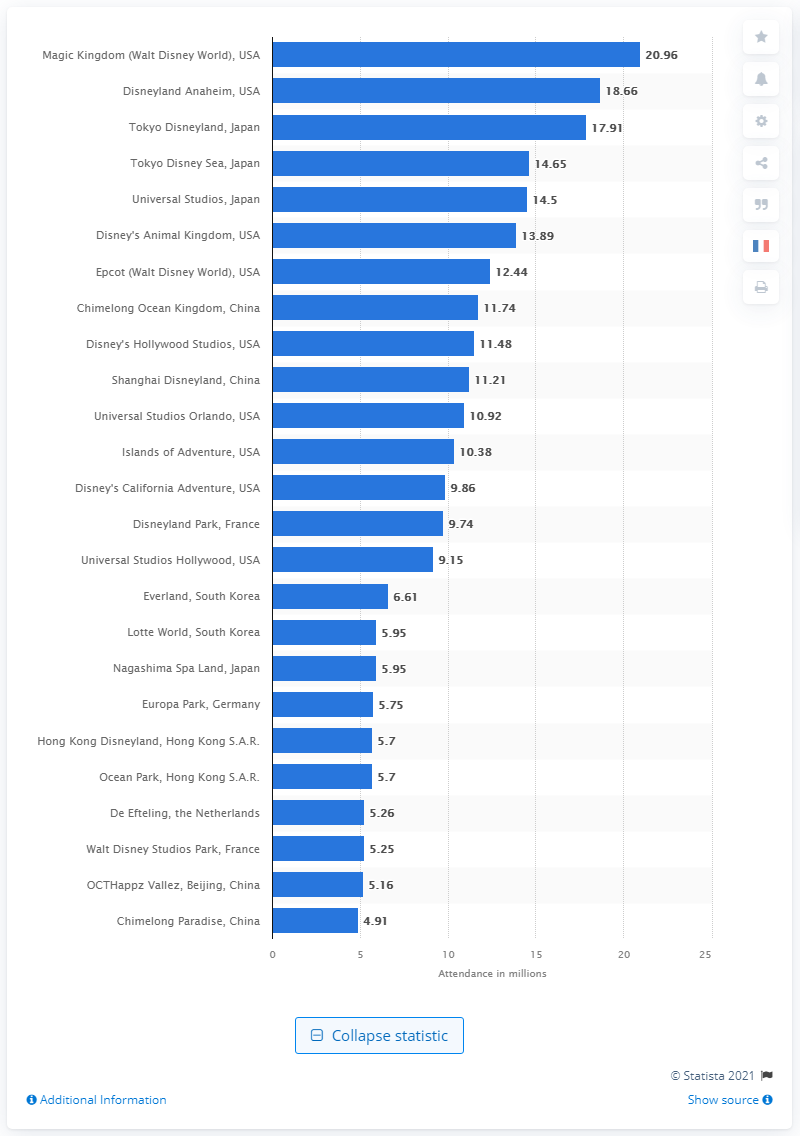Point out several critical features in this image. In 2019, Walt Disney World was visited by 20,960,000 people. 